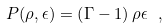<formula> <loc_0><loc_0><loc_500><loc_500>P ( \rho , \epsilon ) = \left ( \Gamma - 1 \right ) \rho \epsilon \ ,</formula> 